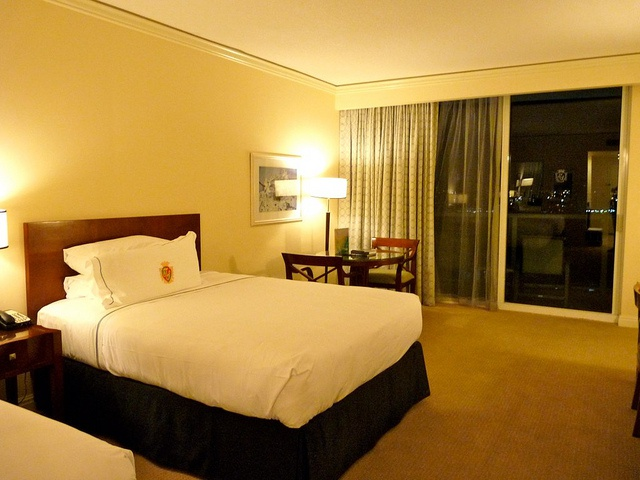Describe the objects in this image and their specific colors. I can see bed in orange, tan, black, and maroon tones, bed in orange, tan, olive, and black tones, chair in black, gray, and orange tones, chair in orange, black, maroon, and olive tones, and chair in orange, black, and maroon tones in this image. 